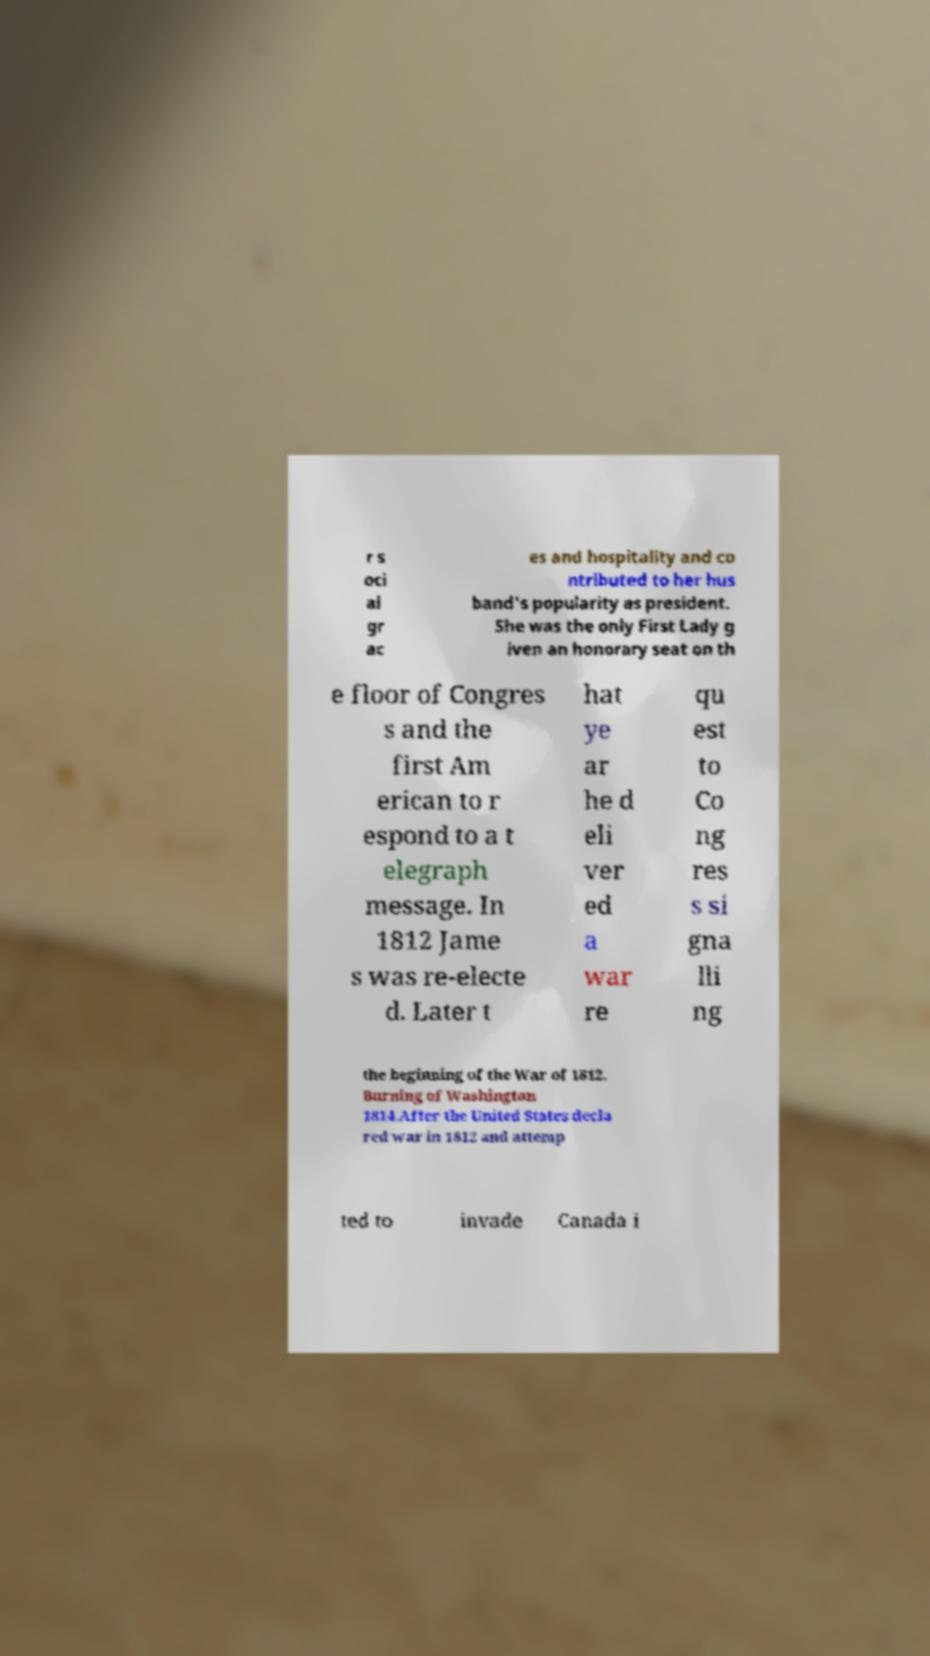I need the written content from this picture converted into text. Can you do that? r s oci al gr ac es and hospitality and co ntributed to her hus band's popularity as president. She was the only First Lady g iven an honorary seat on th e floor of Congres s and the first Am erican to r espond to a t elegraph message. In 1812 Jame s was re-electe d. Later t hat ye ar he d eli ver ed a war re qu est to Co ng res s si gna lli ng the beginning of the War of 1812. Burning of Washington 1814.After the United States decla red war in 1812 and attemp ted to invade Canada i 